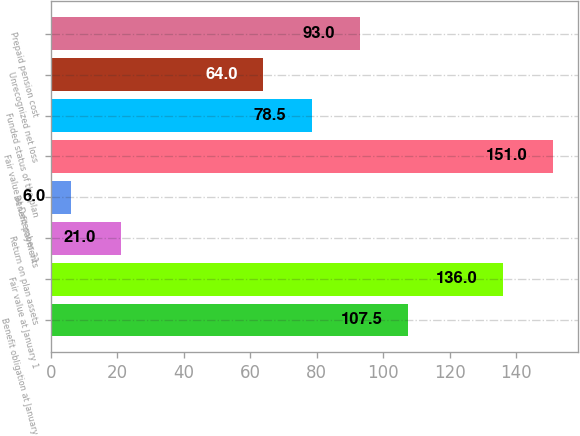<chart> <loc_0><loc_0><loc_500><loc_500><bar_chart><fcel>Benefit obligation at January<fcel>Fair value at January 1<fcel>Return on plan assets<fcel>Benefit payments<fcel>Fair value at December 31<fcel>Funded status of the plan<fcel>Unrecognized net loss<fcel>Prepaid pension cost<nl><fcel>107.5<fcel>136<fcel>21<fcel>6<fcel>151<fcel>78.5<fcel>64<fcel>93<nl></chart> 